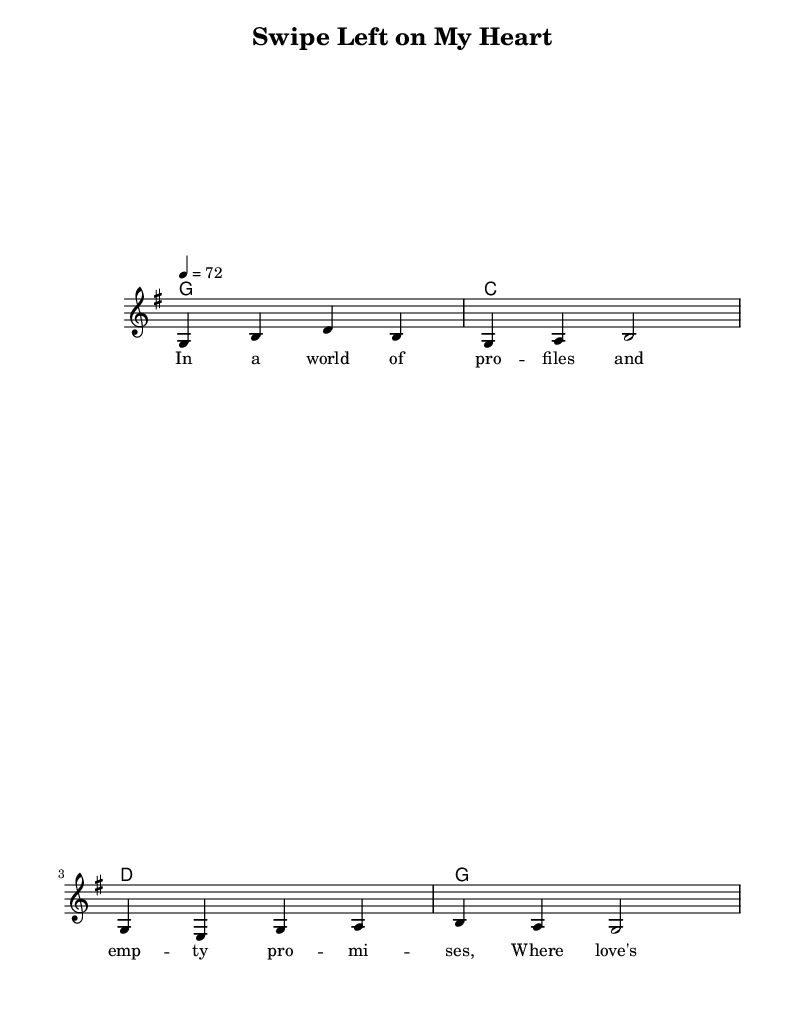What is the key signature of this music? The key signature indicated in the piece is G major, which has one sharp (F#). This can be identified by checking the key signature notation located at the beginning of the staff in the sheet music.
Answer: G major What is the time signature of this music? The time signature is 4/4, which is shown at the beginning of the staff. This means there are four beats in each measure and the quarter note gets one beat.
Answer: 4/4 What is the tempo marking for this piece? The tempo marking of 72 BPM (beats per minute) is indicated at the beginning of the score, specifying how fast the piece should be played.
Answer: 72 How many measures are present in the melody? The melody consists of four measures, which can be counted by observing the divisions marked by vertical lines on the staff.
Answer: Four What is the primary theme expressed in the lyrics? The lyrics reflect a critique of modern dating culture, specifically the superficiality of dating apps and how love is reduced to a mere choice. This can be inferred from the words used, such as "profiles" and "swipe".
Answer: Superficial dating What chords accompany the melody? The chords accompanying the melody are G, C, D, and G, as outlined in the chord mode section of the sheet music. These chords are placed above the staff to indicate their harmonic support for the melody.
Answer: G, C, D, G How does the lyrical structure relate to traditional country ballads? The lyrical structure includes narrative storytelling and emotional expression, common characteristics of traditional country ballads, reflecting personal experiences or social commentary which is illustrated in the lyric text.
Answer: Narrative storytelling 